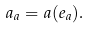<formula> <loc_0><loc_0><loc_500><loc_500>a _ { a } = a ( e _ { a } ) .</formula> 